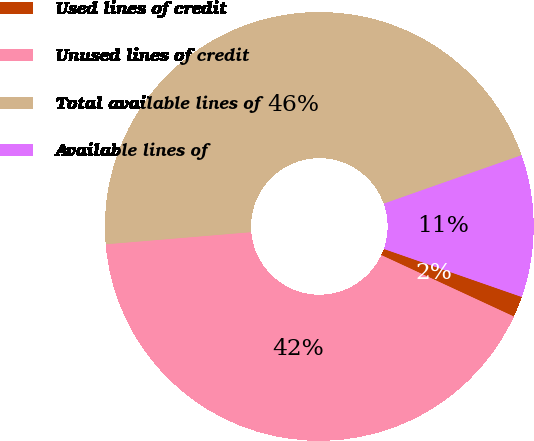<chart> <loc_0><loc_0><loc_500><loc_500><pie_chart><fcel>Used lines of credit<fcel>Unused lines of credit<fcel>Total available lines of<fcel>Available lines of<nl><fcel>1.57%<fcel>41.77%<fcel>45.94%<fcel>10.72%<nl></chart> 